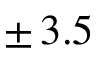<formula> <loc_0><loc_0><loc_500><loc_500>\pm \, 3 . 5</formula> 